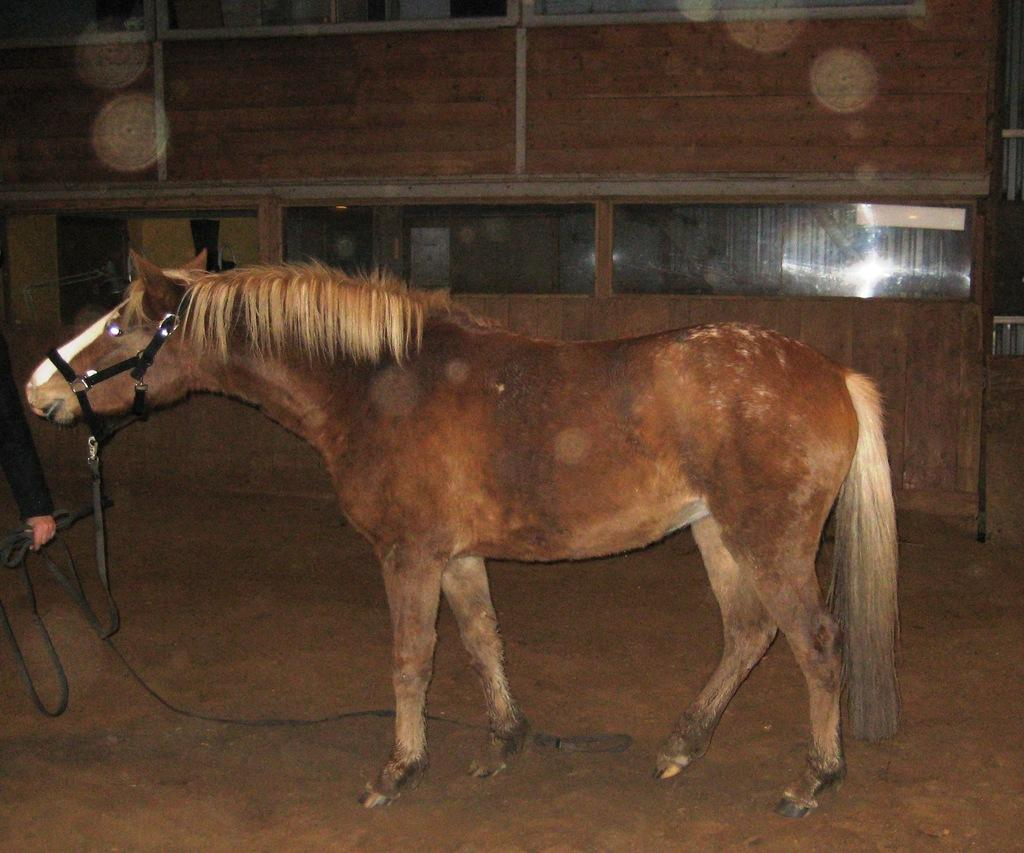What is the main subject in the center of the image? There is an animal standing in the center of the image. Who or what is on the left side of the image? There is a person on the left side of the image. What is the person holding in their hand? The person is holding a rope in their hand. What can be seen in the background of the image? There is a wooden wall in the background of the image. What other object is present in the image? There is a glass in the image. How many ladybugs are crawling on the wooden wall in the image? There are no ladybugs present in the image; only the animal, person, rope, wooden wall, and glass are visible. What type of poison is being used by the person in the image? There is no indication of any poison being used in the image; the person is simply holding a rope. 